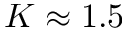Convert formula to latex. <formula><loc_0><loc_0><loc_500><loc_500>K \approx 1 . 5</formula> 